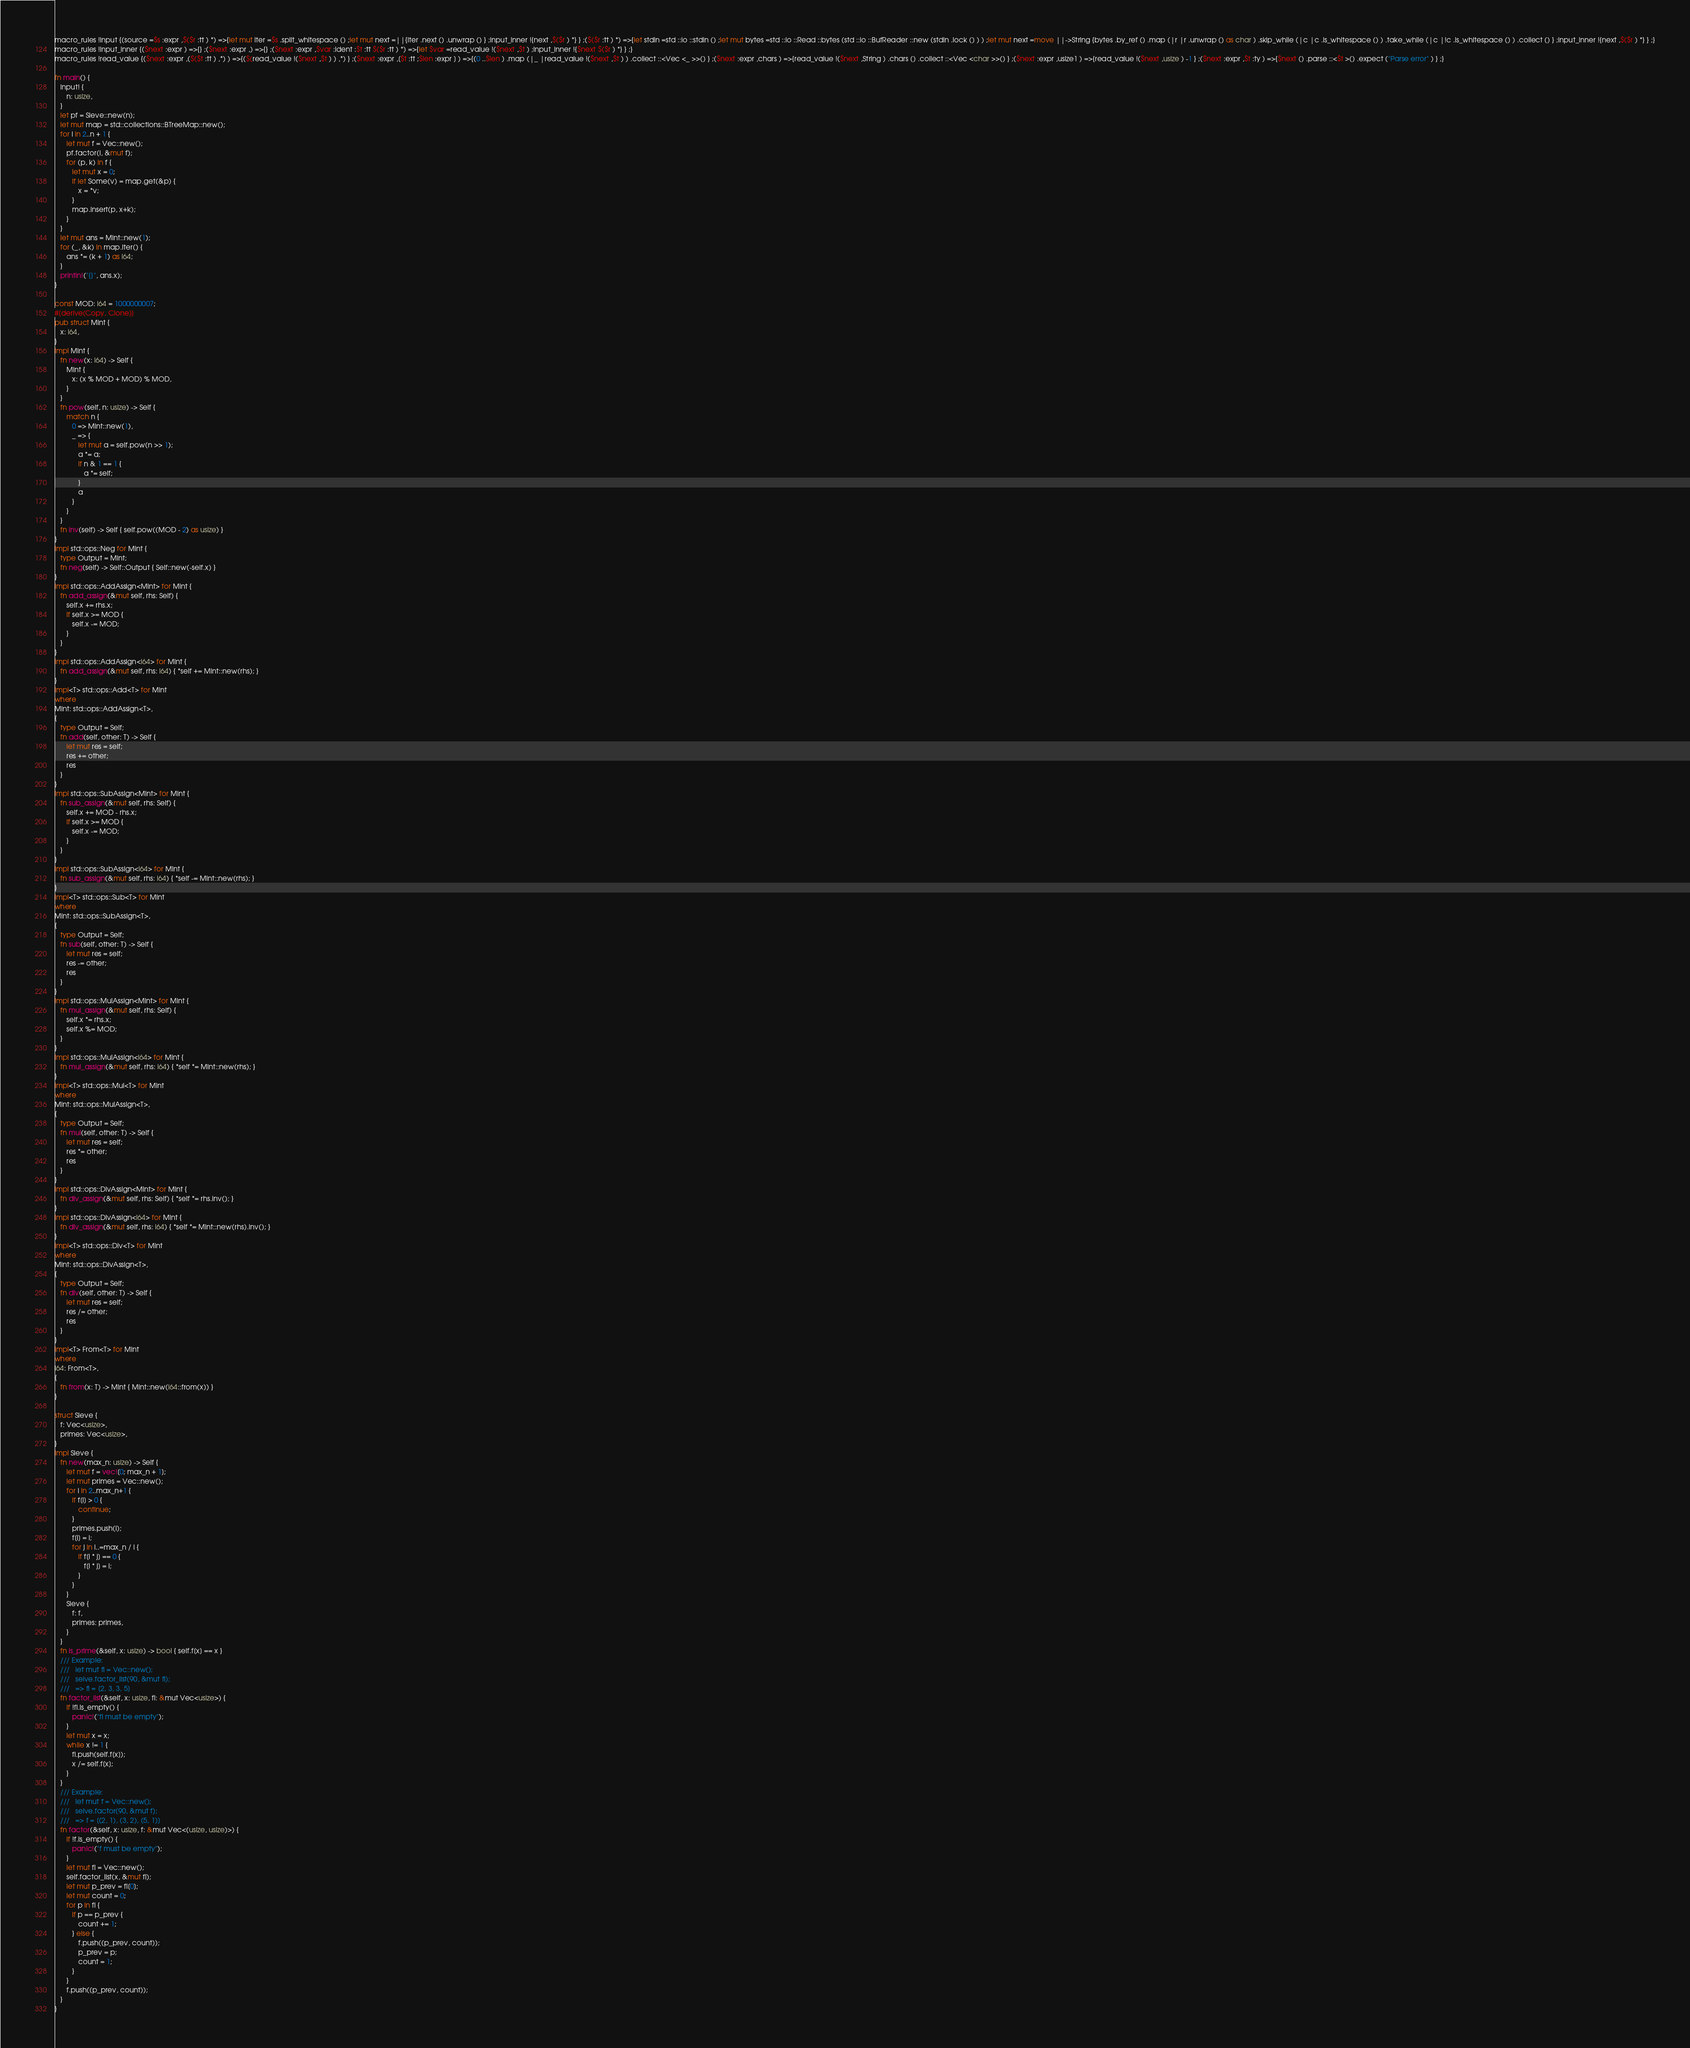<code> <loc_0><loc_0><loc_500><loc_500><_Rust_>macro_rules !input {(source =$s :expr ,$($r :tt ) *) =>{let mut iter =$s .split_whitespace () ;let mut next =||{iter .next () .unwrap () } ;input_inner !{next ,$($r ) *} } ;($($r :tt ) *) =>{let stdin =std ::io ::stdin () ;let mut bytes =std ::io ::Read ::bytes (std ::io ::BufReader ::new (stdin .lock () ) ) ;let mut next =move ||->String {bytes .by_ref () .map (|r |r .unwrap () as char ) .skip_while (|c |c .is_whitespace () ) .take_while (|c |!c .is_whitespace () ) .collect () } ;input_inner !{next ,$($r ) *} } ;}
macro_rules !input_inner {($next :expr ) =>{} ;($next :expr ,) =>{} ;($next :expr ,$var :ident :$t :tt $($r :tt ) *) =>{let $var =read_value !($next ,$t ) ;input_inner !{$next $($r ) *} } ;}
macro_rules !read_value {($next :expr ,($($t :tt ) ,*) ) =>{($(read_value !($next ,$t ) ) ,*) } ;($next :expr ,[$t :tt ;$len :expr ] ) =>{(0 ..$len ) .map (|_ |read_value !($next ,$t ) ) .collect ::<Vec <_ >>() } ;($next :expr ,chars ) =>{read_value !($next ,String ) .chars () .collect ::<Vec <char >>() } ;($next :expr ,usize1 ) =>{read_value !($next ,usize ) -1 } ;($next :expr ,$t :ty ) =>{$next () .parse ::<$t >() .expect ("Parse error" ) } ;}

fn main() {
   input! {
      n: usize,
   }
   let pf = Sieve::new(n);
   let mut map = std::collections::BTreeMap::new();
   for i in 2..n + 1 {
      let mut f = Vec::new();
      pf.factor(i, &mut f);
      for (p, k) in f {
         let mut x = 0;
         if let Some(v) = map.get(&p) {
            x = *v;
         }
         map.insert(p, x+k);
      }
   }
   let mut ans = Mint::new(1);
   for (_, &k) in map.iter() {
      ans *= (k + 1) as i64;
   }
   println!("{}", ans.x);
}

const MOD: i64 = 1000000007;
#[derive(Copy, Clone)]
pub struct Mint {
   x: i64,
}
impl Mint {
   fn new(x: i64) -> Self {
      Mint {
         x: (x % MOD + MOD) % MOD,
      }
   }
   fn pow(self, n: usize) -> Self {
      match n {
         0 => Mint::new(1),
         _ => {
            let mut a = self.pow(n >> 1);
            a *= a;
            if n & 1 == 1 {
               a *= self;
            }
            a
         }
      }
   }
   fn inv(self) -> Self { self.pow((MOD - 2) as usize) }
}
impl std::ops::Neg for Mint {
   type Output = Mint;
   fn neg(self) -> Self::Output { Self::new(-self.x) }
}
impl std::ops::AddAssign<Mint> for Mint {
   fn add_assign(&mut self, rhs: Self) {
      self.x += rhs.x;
      if self.x >= MOD {
         self.x -= MOD;
      }
   }
}
impl std::ops::AddAssign<i64> for Mint {
   fn add_assign(&mut self, rhs: i64) { *self += Mint::new(rhs); }
}
impl<T> std::ops::Add<T> for Mint
where
Mint: std::ops::AddAssign<T>,
{
   type Output = Self;
   fn add(self, other: T) -> Self {
      let mut res = self;
      res += other;
      res
   }
}
impl std::ops::SubAssign<Mint> for Mint {
   fn sub_assign(&mut self, rhs: Self) {
      self.x += MOD - rhs.x;
      if self.x >= MOD {
         self.x -= MOD;
      }
   }
}
impl std::ops::SubAssign<i64> for Mint {
   fn sub_assign(&mut self, rhs: i64) { *self -= Mint::new(rhs); }
}
impl<T> std::ops::Sub<T> for Mint
where
Mint: std::ops::SubAssign<T>,
{
   type Output = Self;
   fn sub(self, other: T) -> Self {
      let mut res = self;
      res -= other;
      res
   }
}
impl std::ops::MulAssign<Mint> for Mint {
   fn mul_assign(&mut self, rhs: Self) {
      self.x *= rhs.x;
      self.x %= MOD;
   }
}
impl std::ops::MulAssign<i64> for Mint {
   fn mul_assign(&mut self, rhs: i64) { *self *= Mint::new(rhs); }
}
impl<T> std::ops::Mul<T> for Mint
where
Mint: std::ops::MulAssign<T>,
{
   type Output = Self;
   fn mul(self, other: T) -> Self {
      let mut res = self;
      res *= other;
      res
   }
}
impl std::ops::DivAssign<Mint> for Mint {
   fn div_assign(&mut self, rhs: Self) { *self *= rhs.inv(); }
}
impl std::ops::DivAssign<i64> for Mint {
   fn div_assign(&mut self, rhs: i64) { *self *= Mint::new(rhs).inv(); }
}
impl<T> std::ops::Div<T> for Mint
where
Mint: std::ops::DivAssign<T>,
{
   type Output = Self;
   fn div(self, other: T) -> Self {
      let mut res = self;
      res /= other;
      res
   }
}
impl<T> From<T> for Mint
where
i64: From<T>,
{
   fn from(x: T) -> Mint { Mint::new(i64::from(x)) }
}

struct Sieve {
   f: Vec<usize>,
   primes: Vec<usize>,
}
impl Sieve {
   fn new(max_n: usize) -> Self {
      let mut f = vec![0; max_n + 1];
      let mut primes = Vec::new();
      for i in 2..max_n+1 {
         if f[i] > 0 {
            continue;
         }
         primes.push(i);
         f[i] = i;
         for j in i..=max_n / i {
            if f[i * j] == 0 {
               f[i * j] = i;
            }
         }
      }
      Sieve {
         f: f,
         primes: primes,
      }
   }
   fn is_prime(&self, x: usize) -> bool { self.f[x] == x }
   /// Example:
   ///   let mut fl = Vec::new();
   ///   seive.factor_list(90, &mut fl);
   ///   => fl = [2, 3, 3, 5]
   fn factor_list(&self, x: usize, fl: &mut Vec<usize>) {
      if !fl.is_empty() {
         panic!("fl must be empty");
      }
      let mut x = x;
      while x != 1 {
         fl.push(self.f[x]);
         x /= self.f[x];
      }
   }
   /// Example:
   ///   let mut f = Vec::new();
   ///   seive.factor(90, &mut f);
   ///   => f = [(2, 1), (3, 2), (5, 1)]
   fn factor(&self, x: usize, f: &mut Vec<(usize, usize)>) {
      if !f.is_empty() {
         panic!("f must be empty");
      }
      let mut fl = Vec::new();
      self.factor_list(x, &mut fl);
      let mut p_prev = fl[0];
      let mut count = 0;
      for p in fl {
         if p == p_prev {
            count += 1;
         } else {
            f.push((p_prev, count));
            p_prev = p;
            count = 1;
         }
      }
      f.push((p_prev, count));
   }
}
</code> 